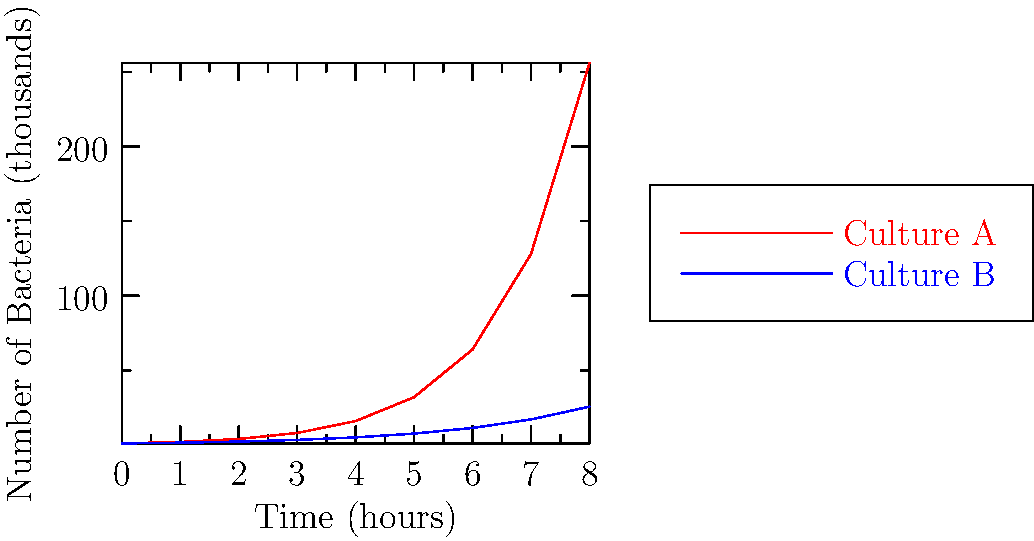As a lab director, you're reviewing data from two bacterial cultures grown over 8 hours. Culture A (red) shows exponential growth, while Culture B (blue) exhibits slower growth. At what hour does the difference in bacterial count between Culture A and Culture B first exceed 50,000 bacteria? To solve this problem, we need to compare the bacterial counts of Culture A and B at each hour:

1. At 0 hours: Both cultures start at 1,000 bacteria (1 on the y-axis represents 1,000)
2. At 1 hour: A = 2,000, B = 1,500; Difference = 500
3. At 2 hours: A = 4,000, B = 2,250; Difference = 1,750
4. At 3 hours: A = 8,000, B = 3,375; Difference = 4,625
5. At 4 hours: A = 16,000, B = 5,062.5; Difference = 10,937.5
6. At 5 hours: A = 32,000, B = 7,593.75; Difference = 24,406.25
7. At 6 hours: A = 64,000, B = 11,390.625; Difference = 52,609.375

The difference first exceeds 50,000 bacteria at the 6-hour mark.

As a lab director, this information is crucial for understanding growth rates and planning experiments. The exponential growth of Culture A might require more frequent monitoring or different containment measures compared to the slower-growing Culture B.
Answer: 6 hours 